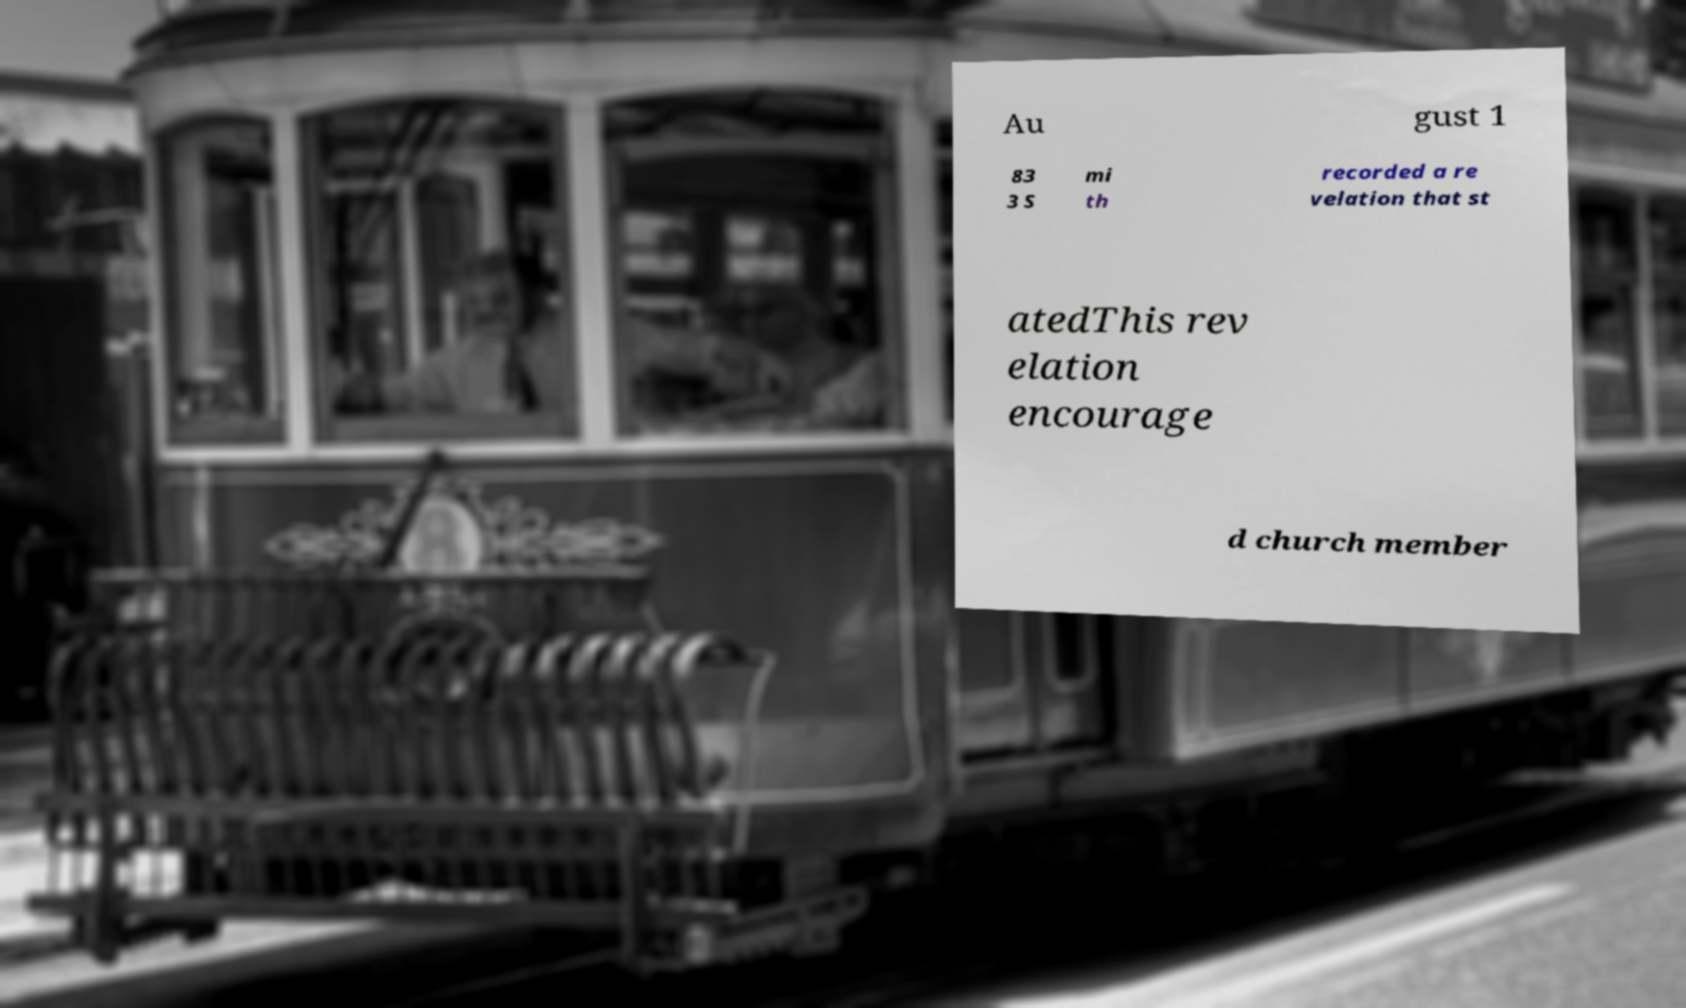There's text embedded in this image that I need extracted. Can you transcribe it verbatim? Au gust 1 83 3 S mi th recorded a re velation that st atedThis rev elation encourage d church member 